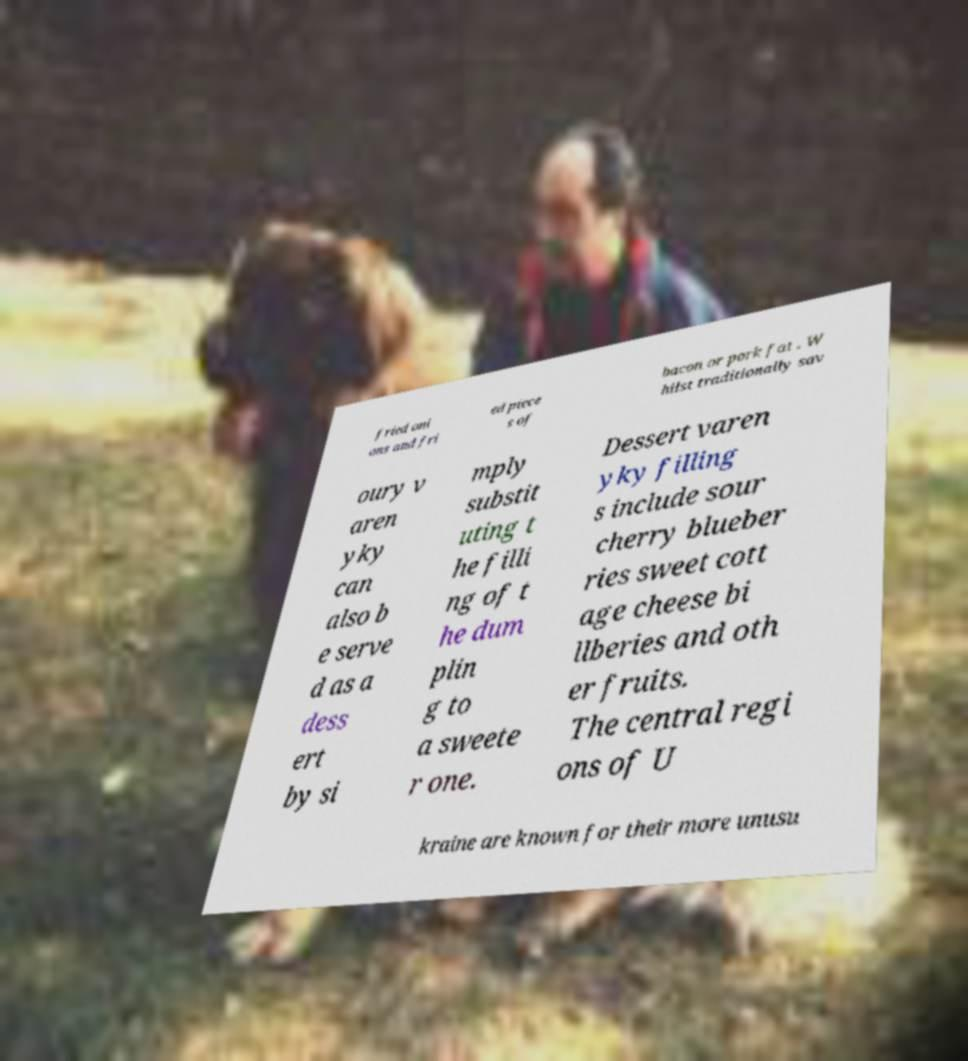Please read and relay the text visible in this image. What does it say? fried oni ons and fri ed piece s of bacon or pork fat . W hilst traditionally sav oury v aren yky can also b e serve d as a dess ert by si mply substit uting t he filli ng of t he dum plin g to a sweete r one. Dessert varen yky filling s include sour cherry blueber ries sweet cott age cheese bi llberies and oth er fruits. The central regi ons of U kraine are known for their more unusu 